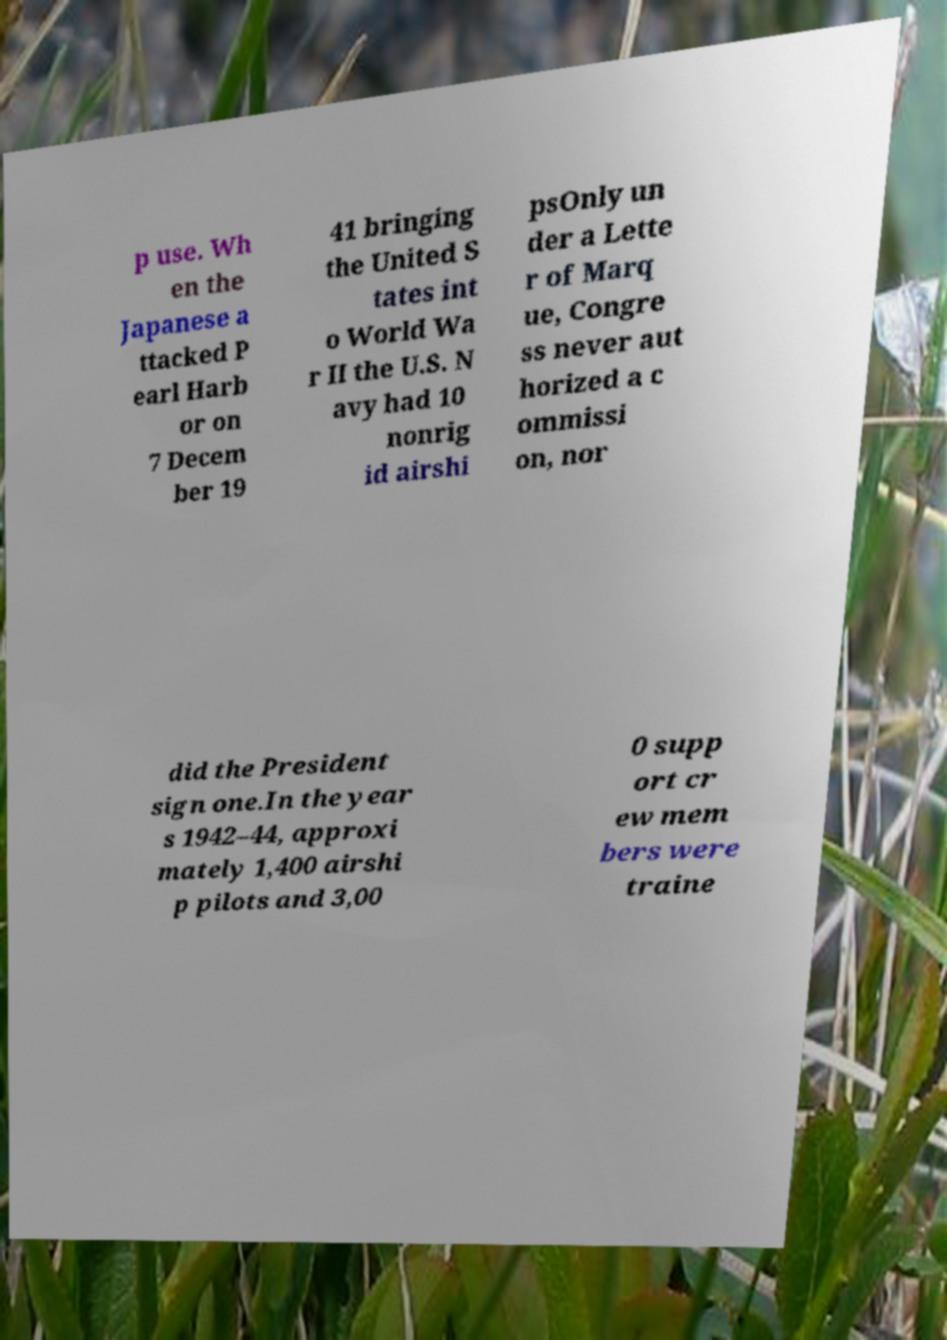I need the written content from this picture converted into text. Can you do that? p use. Wh en the Japanese a ttacked P earl Harb or on 7 Decem ber 19 41 bringing the United S tates int o World Wa r II the U.S. N avy had 10 nonrig id airshi psOnly un der a Lette r of Marq ue, Congre ss never aut horized a c ommissi on, nor did the President sign one.In the year s 1942–44, approxi mately 1,400 airshi p pilots and 3,00 0 supp ort cr ew mem bers were traine 